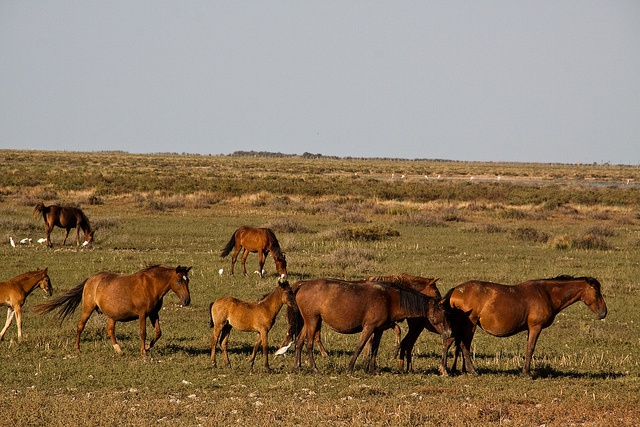Describe the objects in this image and their specific colors. I can see horse in darkgray, maroon, black, and brown tones, horse in darkgray, maroon, black, and brown tones, horse in darkgray, brown, maroon, and black tones, horse in darkgray, brown, maroon, and black tones, and horse in darkgray, black, maroon, and brown tones in this image. 